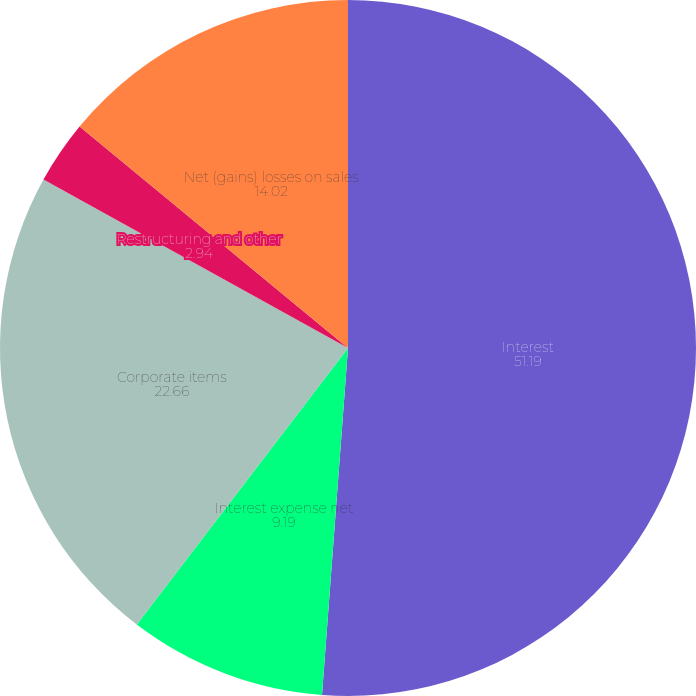<chart> <loc_0><loc_0><loc_500><loc_500><pie_chart><fcel>Interest<fcel>Interest expense net<fcel>Corporate items<fcel>Restructuring and other<fcel>Net (gains) losses on sales<nl><fcel>51.19%<fcel>9.19%<fcel>22.66%<fcel>2.94%<fcel>14.02%<nl></chart> 